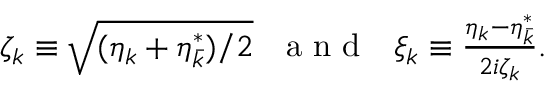Convert formula to latex. <formula><loc_0><loc_0><loc_500><loc_500>\begin{array} { r } { \zeta _ { k } \equiv \sqrt { ( \eta _ { k } + \eta _ { \bar { k } } ^ { * } ) / 2 } \ \ a n d \quad x i _ { k } \equiv \frac { \eta _ { k } - \eta _ { \bar { k } } ^ { * } } { 2 i \zeta _ { k } } . } \end{array}</formula> 